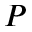<formula> <loc_0><loc_0><loc_500><loc_500>P</formula> 